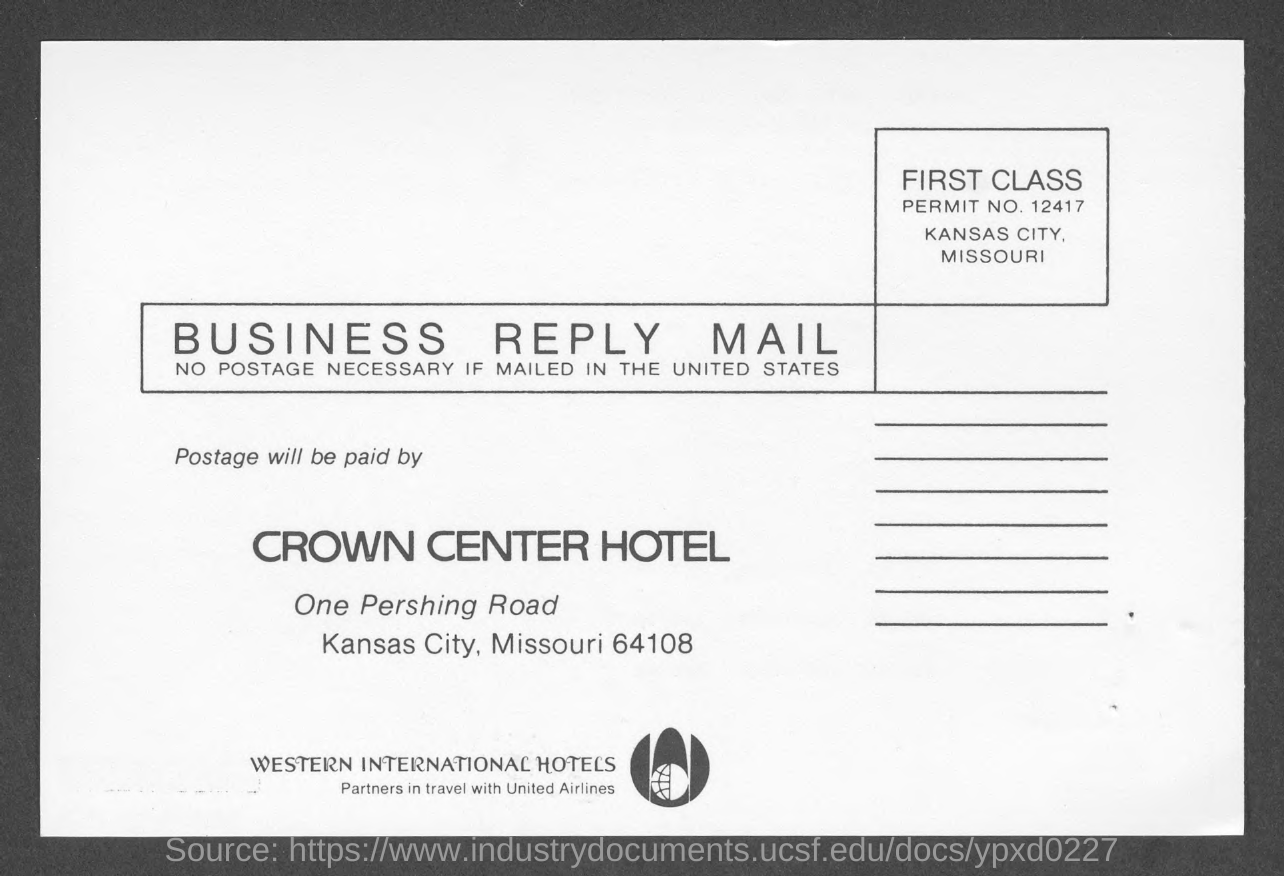In which city is crown center hotel at ?
Keep it short and to the point. Kansas City. What is the permit no.?
Provide a succinct answer. 12417. 